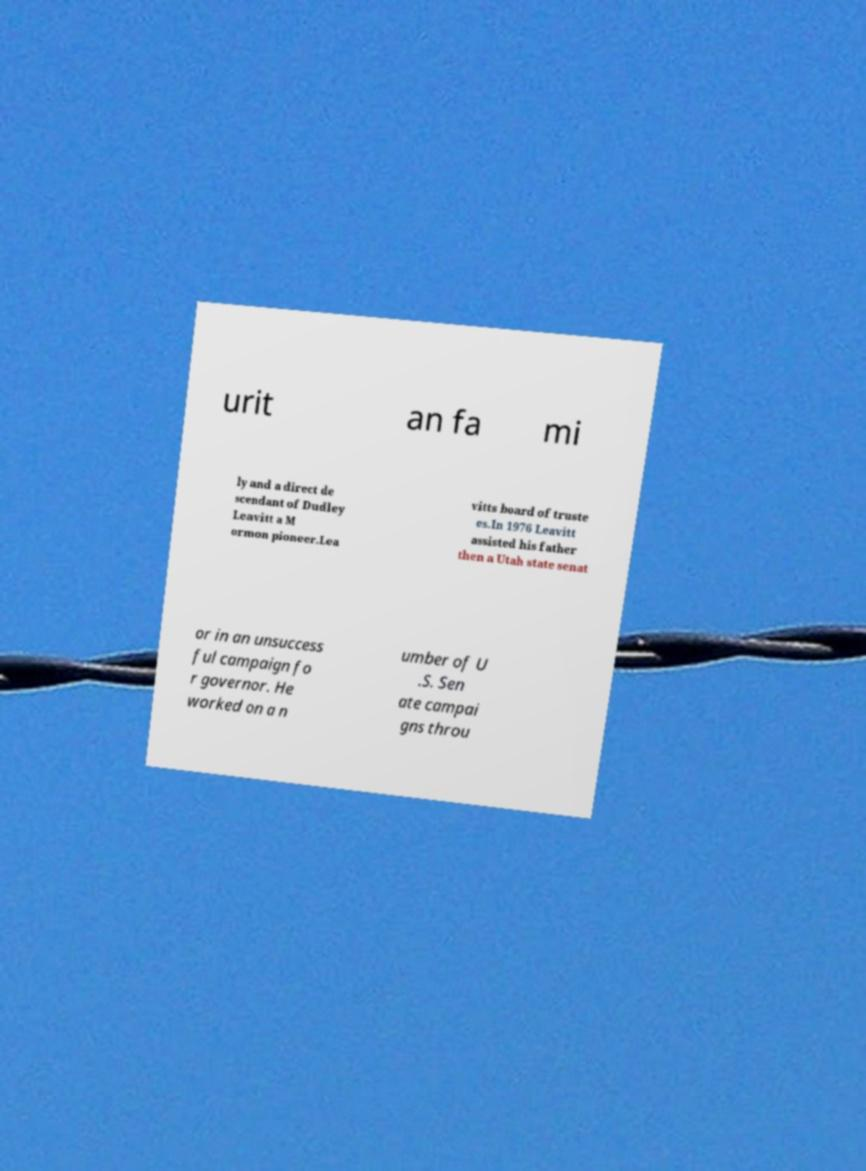Could you assist in decoding the text presented in this image and type it out clearly? urit an fa mi ly and a direct de scendant of Dudley Leavitt a M ormon pioneer.Lea vitts board of truste es.In 1976 Leavitt assisted his father then a Utah state senat or in an unsuccess ful campaign fo r governor. He worked on a n umber of U .S. Sen ate campai gns throu 